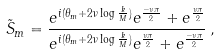<formula> <loc_0><loc_0><loc_500><loc_500>\tilde { S } _ { m } = \frac { e ^ { i ( \theta _ { m } + 2 \nu \log \frac { k } { M } ) } e ^ { \frac { - \nu \pi } { 2 } } + e ^ { \frac { \nu \pi } { 2 } } } { e ^ { i ( \theta _ { m } + 2 \nu \log \frac { k } { M } ) } e ^ { \frac { \nu \pi } { 2 } } + e ^ { \frac { - \nu \pi } { 2 } } } \, ,</formula> 